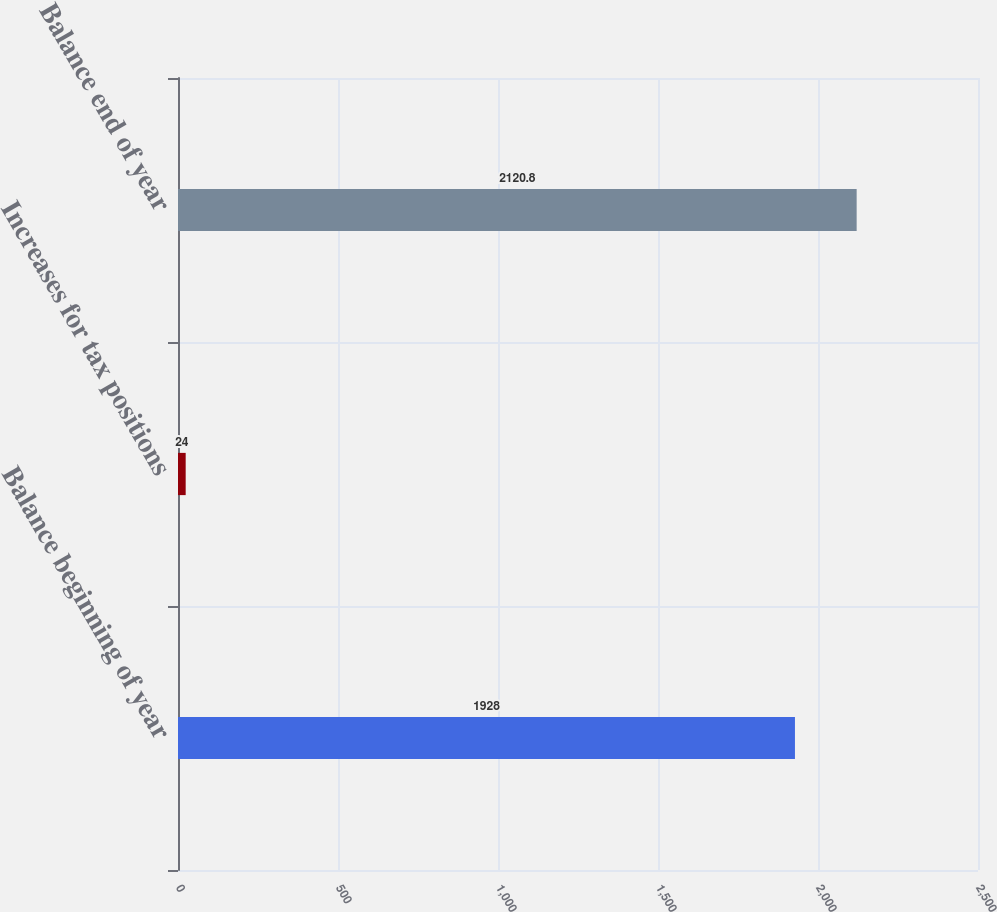<chart> <loc_0><loc_0><loc_500><loc_500><bar_chart><fcel>Balance beginning of year<fcel>Increases for tax positions<fcel>Balance end of year<nl><fcel>1928<fcel>24<fcel>2120.8<nl></chart> 